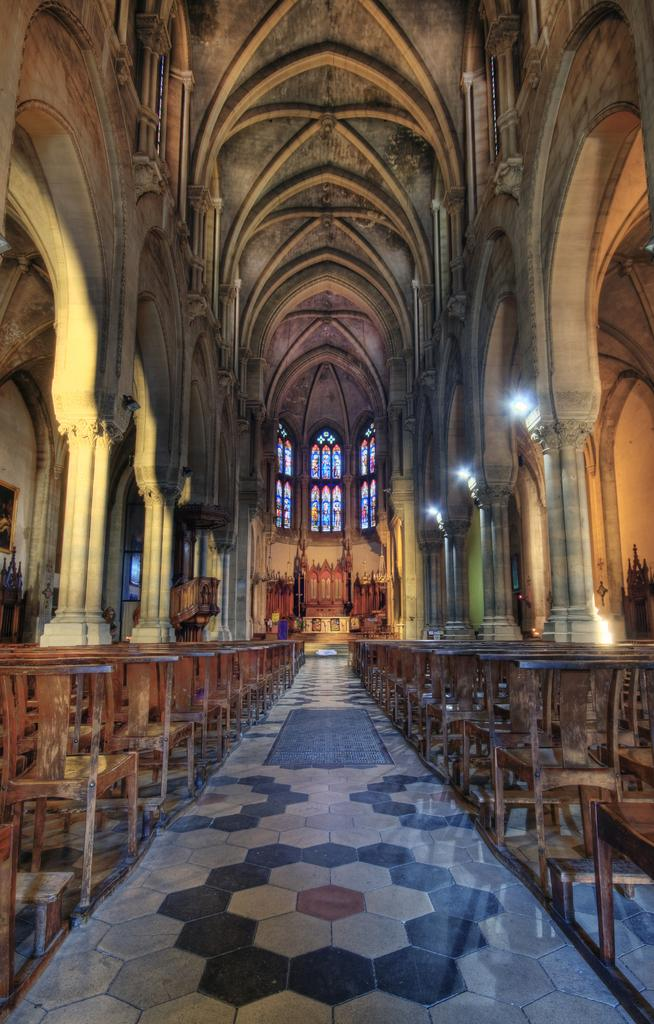What type of location is depicted in the image? The image shows an inner view of a building. What type of furniture can be seen in the image? There are chairs in the image. What type of illumination is present in the image? There are lights in the image. Can you see any fangs in the image? There are no fangs present in the image. Is there a feast taking place in the image? There is no indication of a feast in the image. 